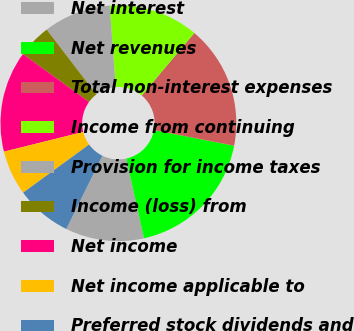Convert chart to OTSL. <chart><loc_0><loc_0><loc_500><loc_500><pie_chart><fcel>Net interest<fcel>Net revenues<fcel>Total non-interest expenses<fcel>Income from continuing<fcel>Provision for income taxes<fcel>Income (loss) from<fcel>Net income<fcel>Net income applicable to<fcel>Preferred stock dividends and<nl><fcel>10.77%<fcel>18.46%<fcel>16.92%<fcel>12.31%<fcel>9.23%<fcel>4.62%<fcel>13.85%<fcel>6.15%<fcel>7.69%<nl></chart> 